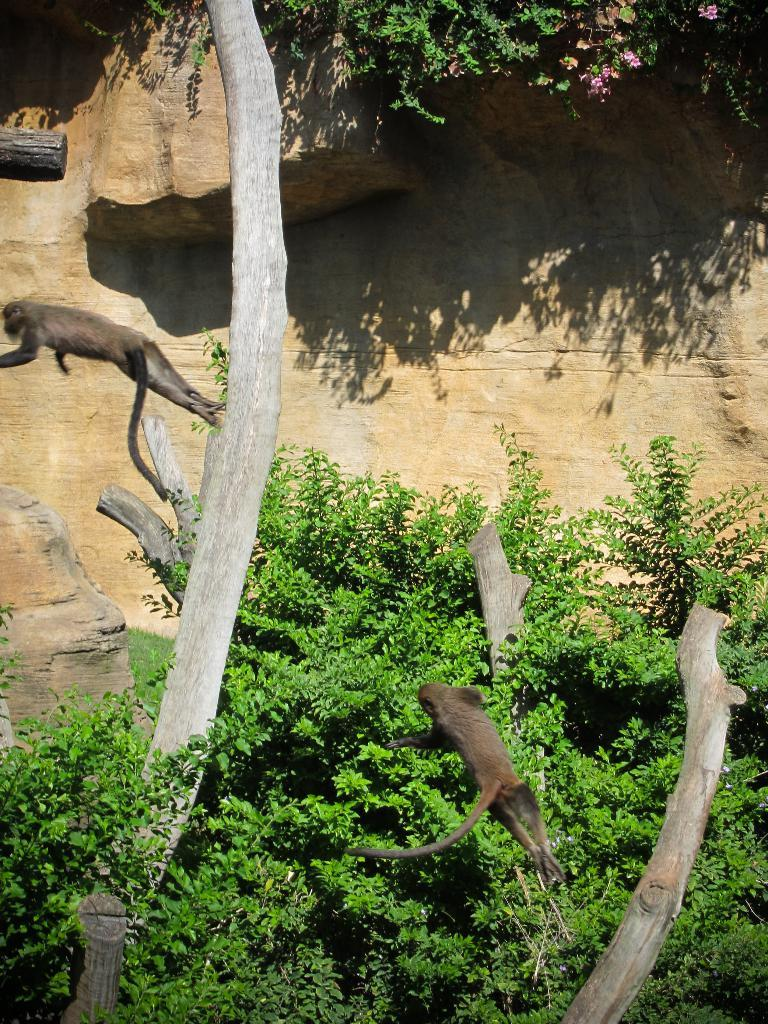What type of vegetation is at the bottom of the picture? There are trees at the bottom of the picture. What are the monkeys doing in the image? Two monkeys are jumping from one tree to another tree. Can you describe any other objects or features in the background of the image? There is a rock visible in the background of the image. Is there any bread visible in the image? No, there is no bread present in the image. Is there a rainstorm happening in the image? No, there is no rainstorm depicted in the image. 